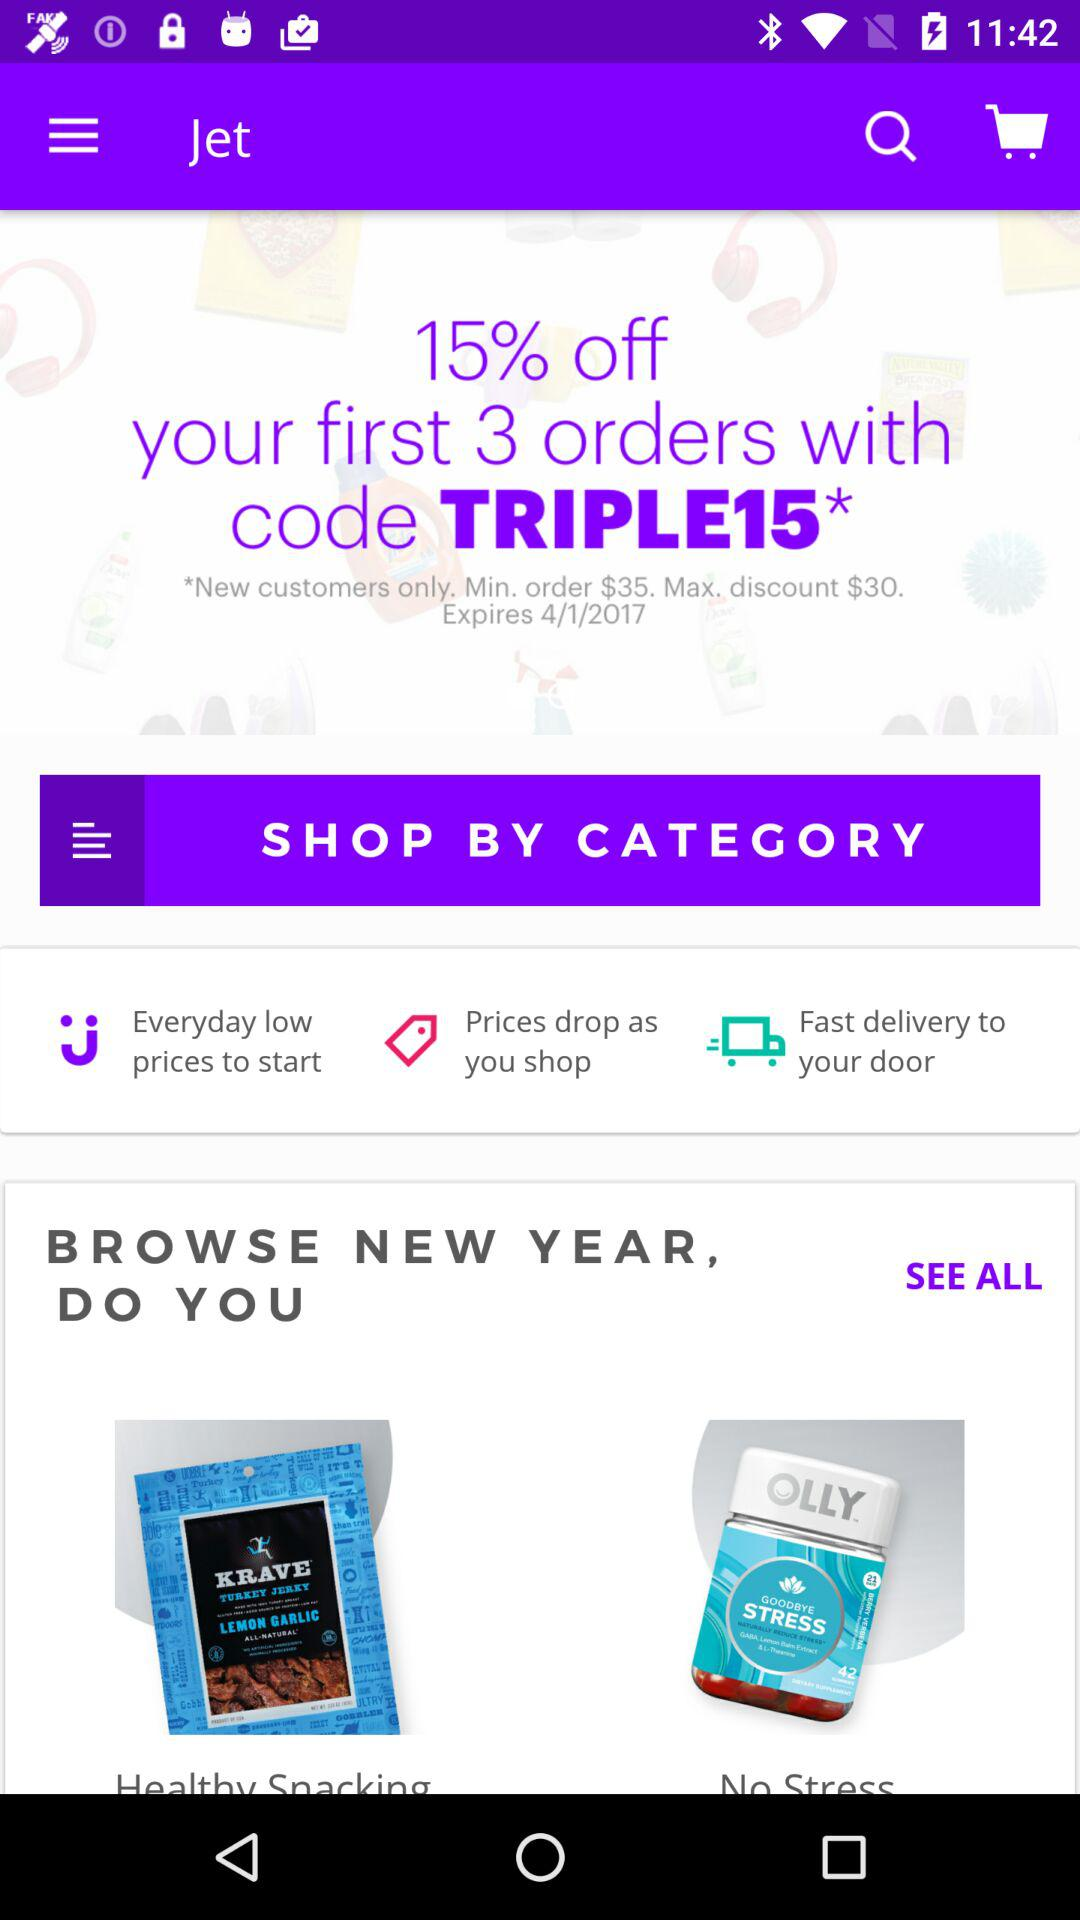What code is used for the discount on the products? The code is TRIPLE*. 